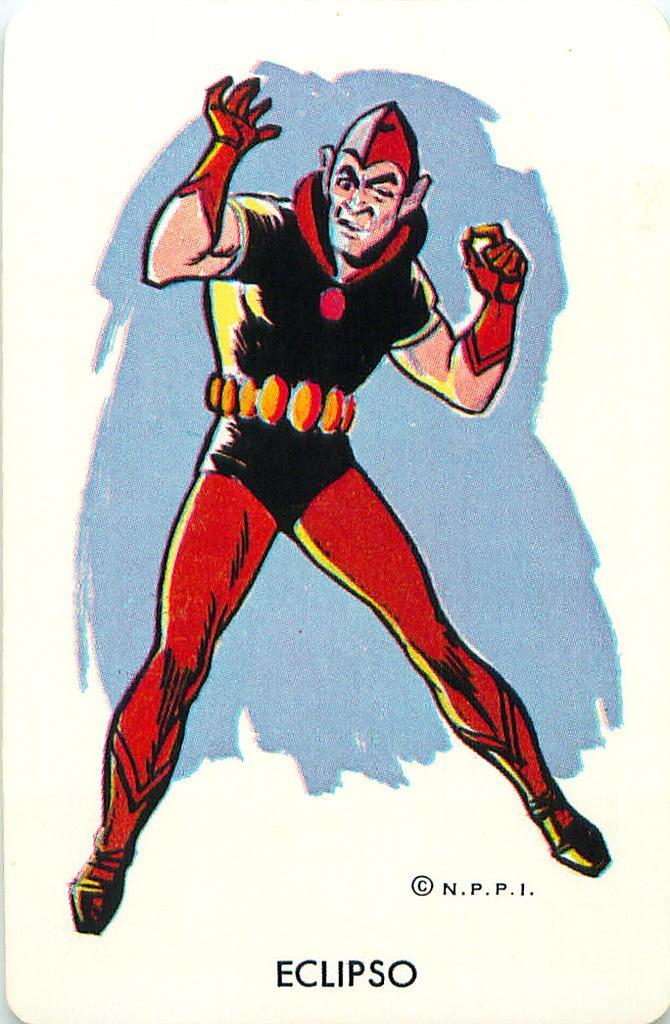Describe this image in one or two sentences. This image consists of a poster in which there is a man wearing red cap and black dress. At the bottom, there is a text. 